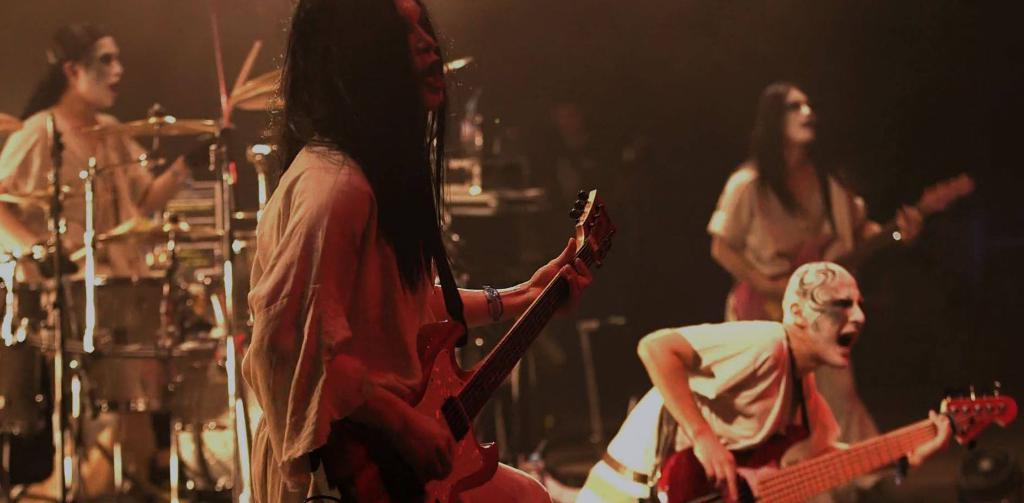How many people are in the image? There are persons in the image. What are the persons in the image doing? The persons are holding musical instruments. Can you tell me what page of the book the person is reading in the image? There is no book or person reading in the image; the persons are holding musical instruments. 